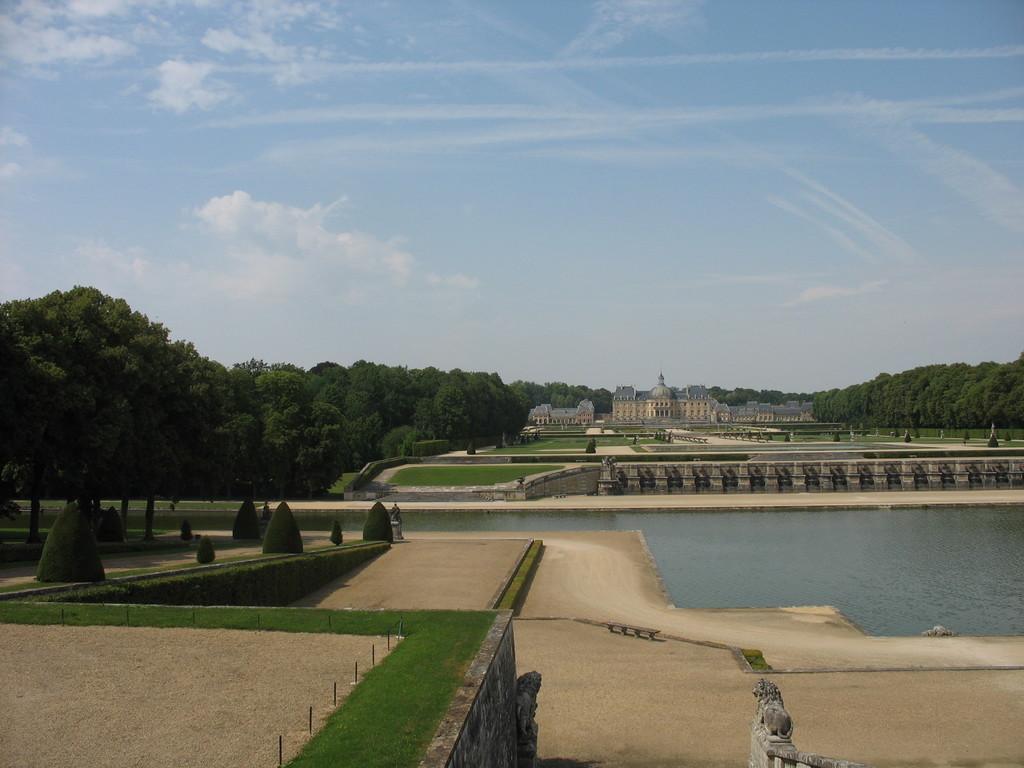Can you describe this image briefly? In the foreground of this image, there is land, grass, few trees and water. In the background, there are trees, grasslands, building and the sky. 